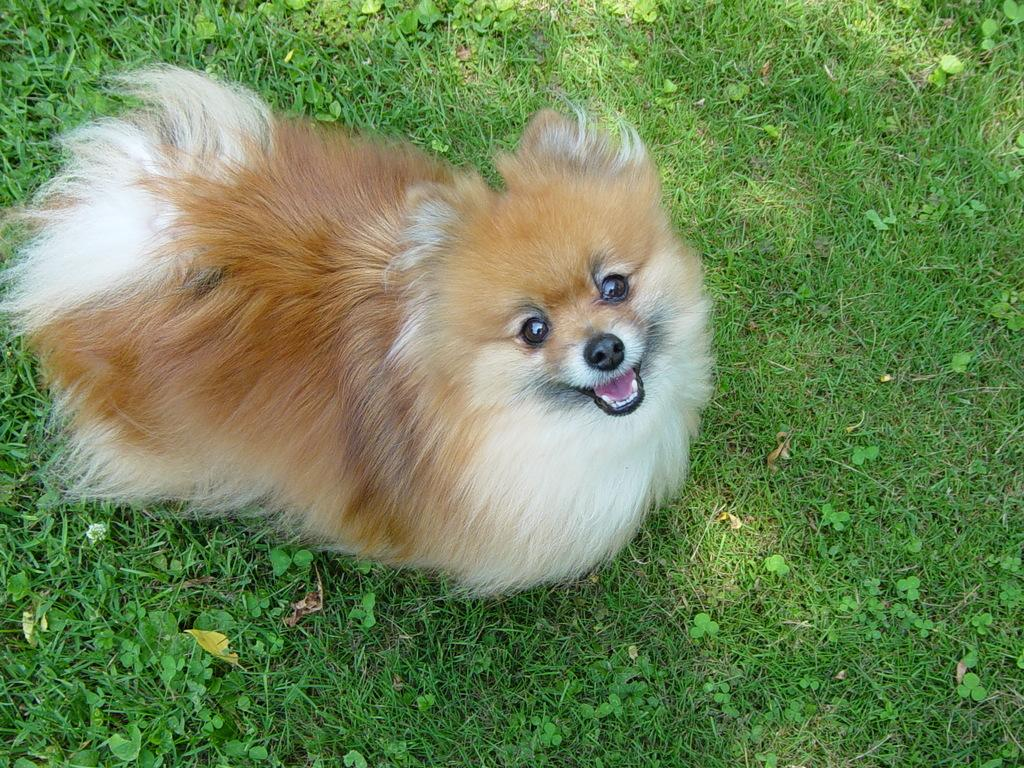What is the main subject in the center of the image? There is a dog in the center of the image. Where is the dog located? The dog is on the ground. What type of plants can be seen in the image? There are herbs visible in the image. What is the natural setting in the image? There is grass visible in the image. What news headline is visible on the dog's collar in the image? There is no news headline visible on the dog's collar in the image, as the dog is not wearing a collar. 